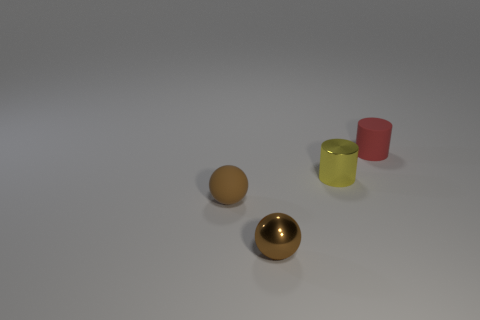What number of objects are either tiny matte objects on the right side of the small yellow shiny cylinder or tiny objects that are in front of the matte cylinder?
Your response must be concise. 4. There is a brown metallic thing that is the same size as the matte cylinder; what shape is it?
Offer a very short reply. Sphere. Is there a tiny purple thing that has the same shape as the yellow thing?
Your response must be concise. No. Are there fewer tiny metal cylinders than red rubber cubes?
Offer a terse response. No. Does the shiny object that is right of the shiny ball have the same size as the matte thing in front of the red matte object?
Your answer should be very brief. Yes. How many objects are either metal balls or large green shiny cubes?
Provide a succinct answer. 1. What is the size of the metallic object left of the tiny yellow metal cylinder?
Offer a very short reply. Small. There is a small ball that is to the right of the matte object left of the red object; what number of brown rubber spheres are on the left side of it?
Offer a terse response. 1. Is the color of the small metallic sphere the same as the rubber cylinder?
Keep it short and to the point. No. How many small objects are on the right side of the matte sphere and in front of the small red rubber thing?
Make the answer very short. 2. 